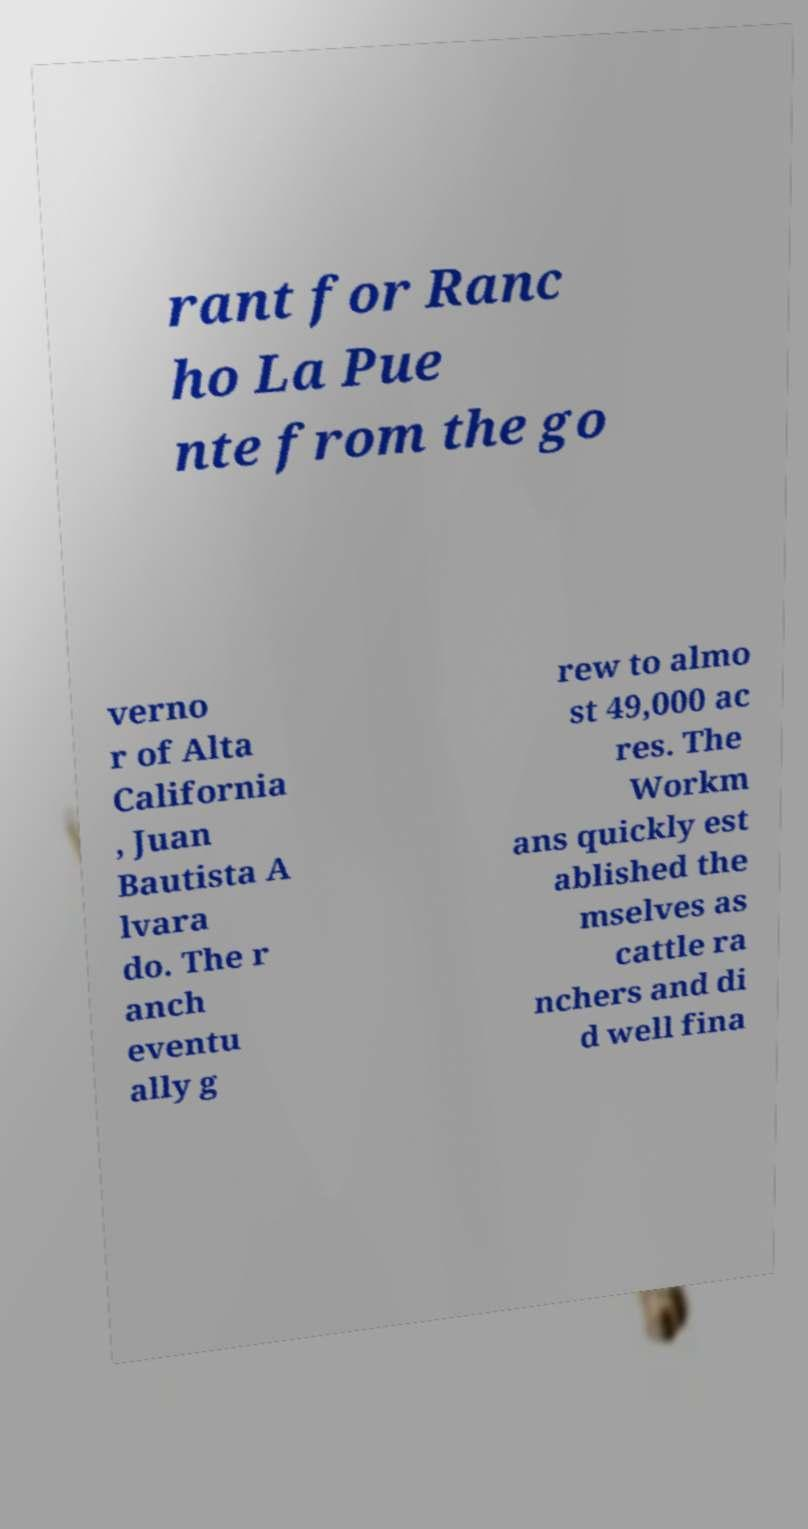Can you read and provide the text displayed in the image?This photo seems to have some interesting text. Can you extract and type it out for me? rant for Ranc ho La Pue nte from the go verno r of Alta California , Juan Bautista A lvara do. The r anch eventu ally g rew to almo st 49,000 ac res. The Workm ans quickly est ablished the mselves as cattle ra nchers and di d well fina 